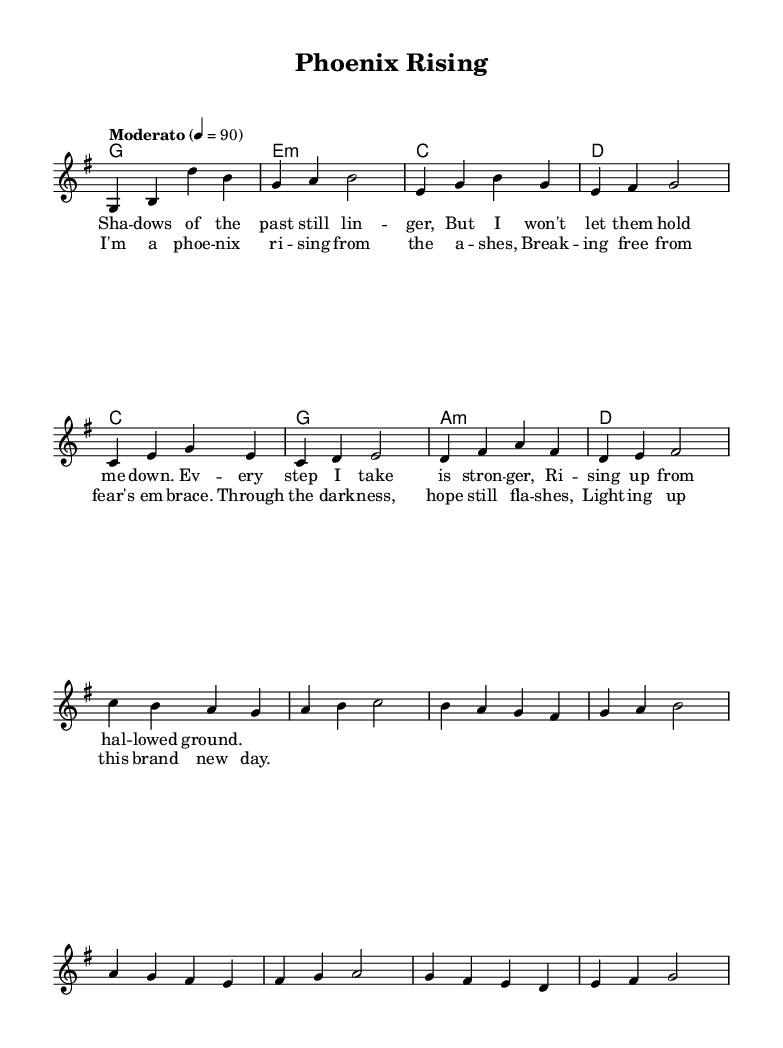What is the key signature of this music? The key signature is indicated at the beginning of the staff. Here, it shows one sharp (F#), which is characteristic of G major.
Answer: G major What is the time signature of this music? The time signature appears at the beginning of the score, displaying a "4/4" notation. This means there are four beats in each measure and a quarter note gets one beat.
Answer: 4/4 What is the tempo marking for this piece? The tempo marking is written above the staff, stating "Moderato" with a beat of 90 per minute. This indicates a moderate pace for the music.
Answer: Moderato 90 How many measures are in the verse of the song? By counting the measures in the melody section titled "Verse" from the sheet music, we see there are 8 measures.
Answer: 8 Which chord follows the D major chord in the harmonies? Looking at the sequence of chords in the harmonies section, after the D major chord, it moves to a C major chord in the verse.
Answer: C major What emotion does the title "Phoenix Rising" suggest about the song? The title suggests themes of resilience and rebirth, drawn from the symbolism of a phoenix which rises from ashes, indicating strength in overcoming adversity.
Answer: Resilience 